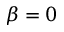Convert formula to latex. <formula><loc_0><loc_0><loc_500><loc_500>\beta = 0</formula> 